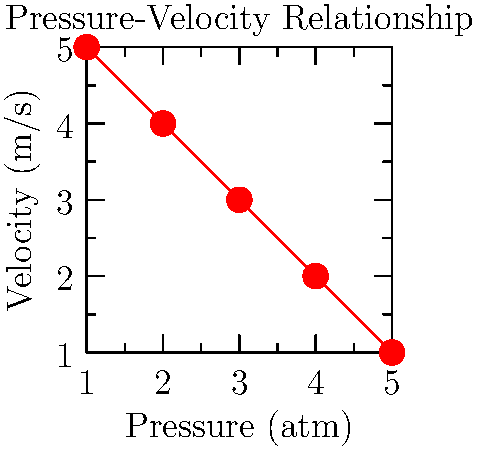In a manufacturing process for industrial piping, you notice that as the fluid pressure increases, its velocity decreases, as shown in the graph. Which principle of fluid dynamics best explains this relationship, and how might it impact the design of your company's fluid transport systems? To answer this question, let's break it down step-by-step:

1. Observe the graph: As pressure increases, velocity decreases.

2. This inverse relationship between pressure and velocity is described by Bernoulli's principle, which states that in a steady flow, an increase in the speed of a fluid occurs simultaneously with a decrease in pressure or a decrease in the fluid's potential energy.

3. Mathematically, Bernoulli's equation is expressed as:

   $$P + \frac{1}{2}\rho v^2 + \rho gh = \text{constant}$$

   Where:
   $P$ = pressure
   $\rho$ = fluid density
   $v$ = fluid velocity
   $g$ = gravitational acceleration
   $h$ = height

4. In a horizontal pipe (where height doesn't change), this simplifies to:

   $$P + \frac{1}{2}\rho v^2 = \text{constant}$$

5. This equation shows that as pressure ($P$) increases, velocity ($v$) must decrease to keep the sum constant.

6. Impact on fluid transport systems:
   a) Pressure control: Need to carefully manage pressure to maintain desired flow rates.
   b) Pipe diameter: Can use varying diameters to control pressure and velocity.
   c) Energy efficiency: Can optimize system design to minimize energy losses.
   d) Safety considerations: Must account for pressure changes to prevent pipe damage or leaks.

7. For a marketing officer, understanding this principle helps in:
   a) Explaining product features related to fluid handling.
   b) Understanding customer needs for pressure and flow control.
   c) Collaborating with engineers on product improvements.
   d) Developing marketing materials that accurately represent product capabilities.
Answer: Bernoulli's principle 